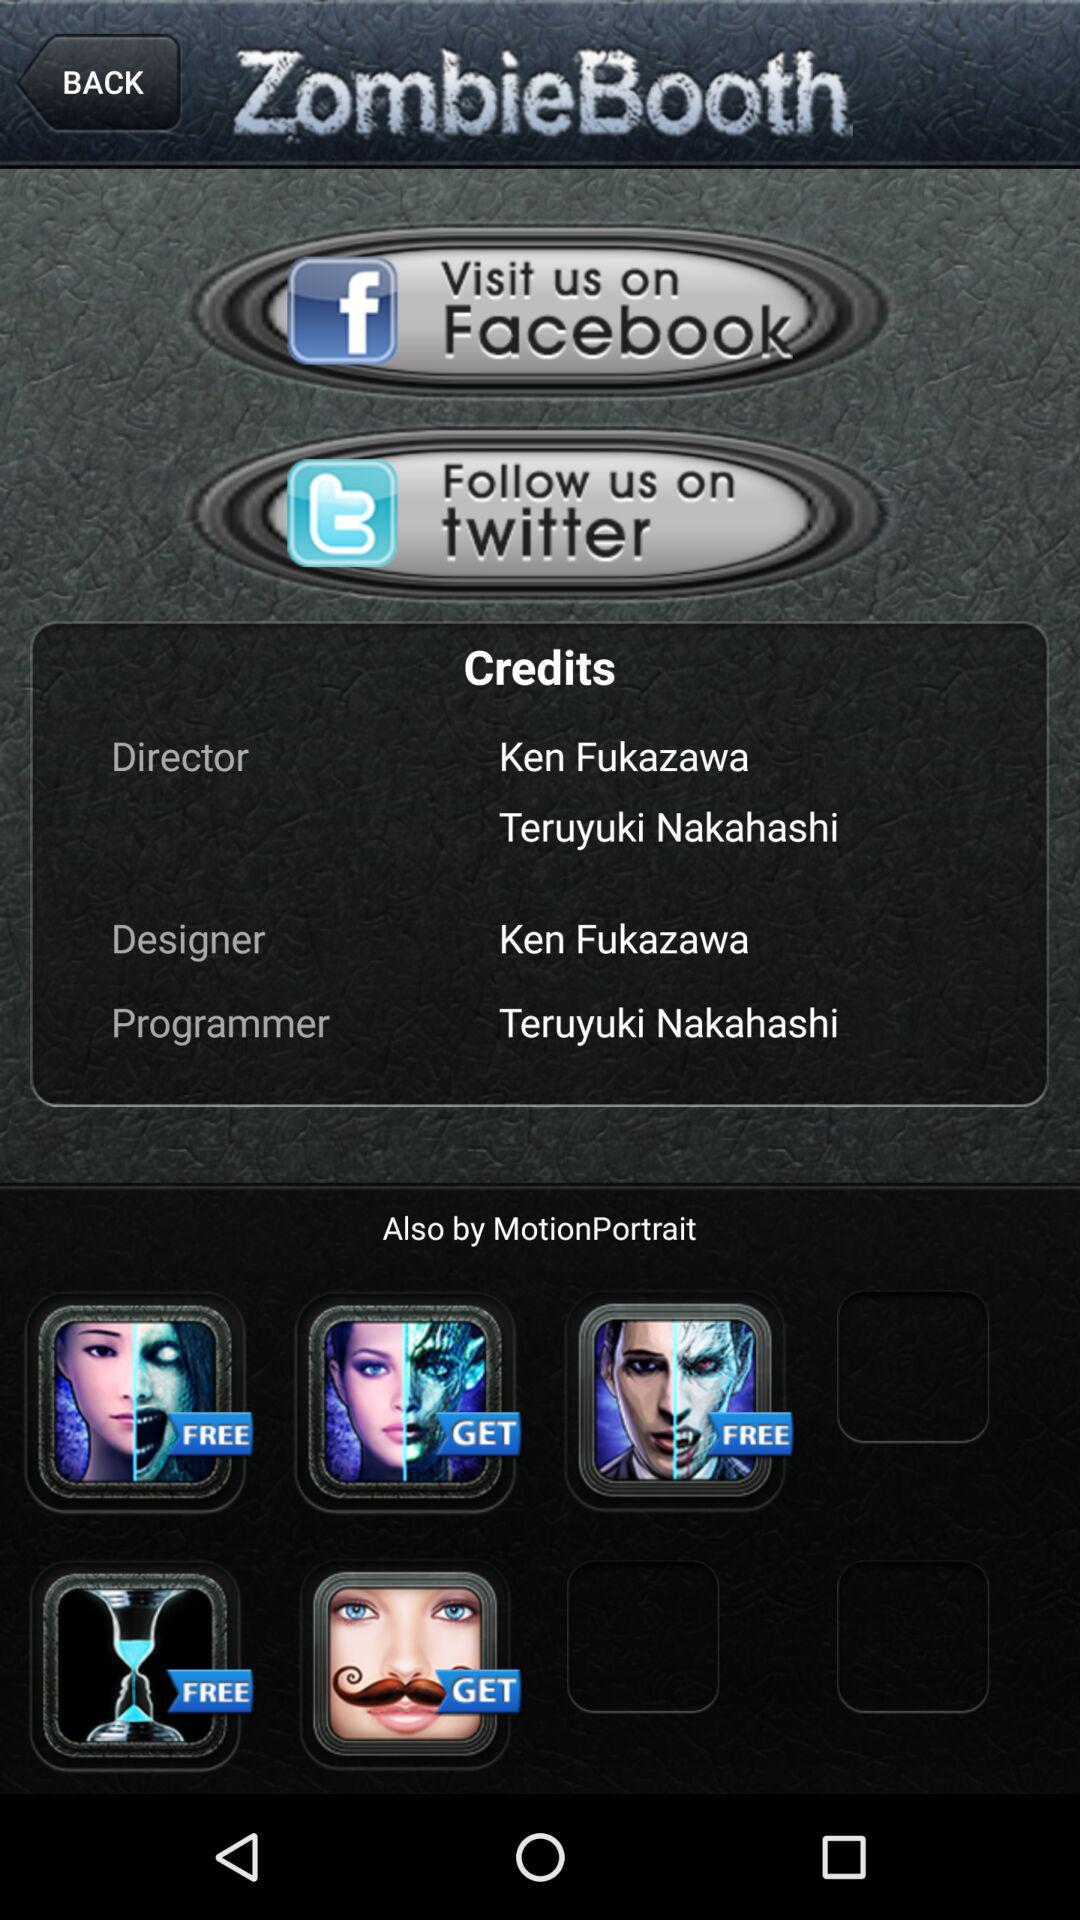What is the name of the programmer? The name of the programmer is Teruyuki Nakahashi. 